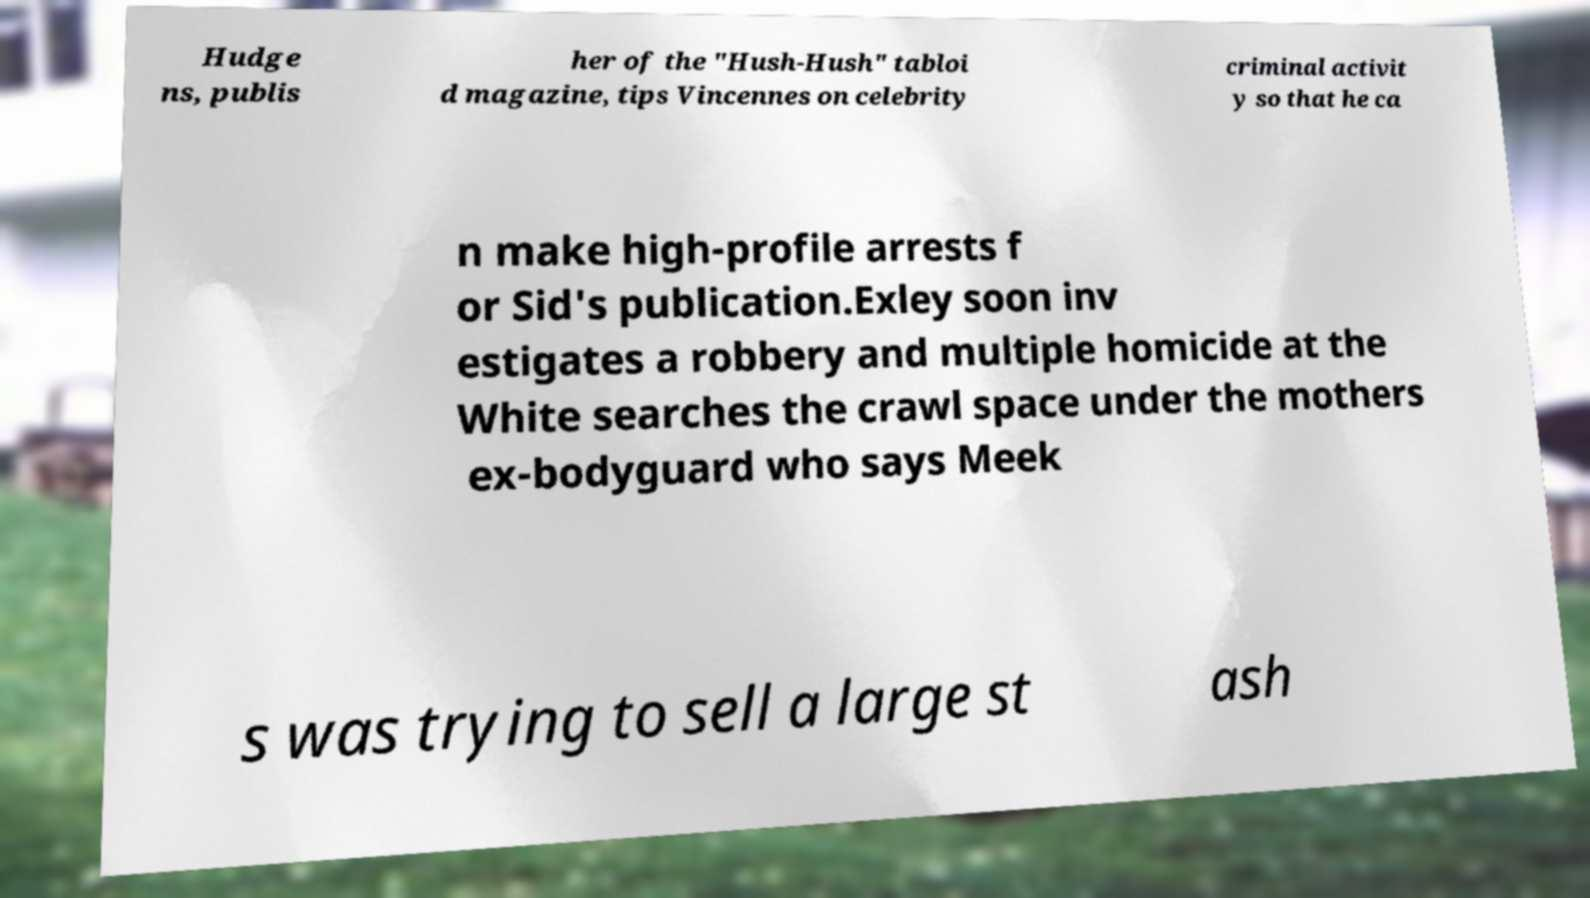I need the written content from this picture converted into text. Can you do that? Hudge ns, publis her of the "Hush-Hush" tabloi d magazine, tips Vincennes on celebrity criminal activit y so that he ca n make high-profile arrests f or Sid's publication.Exley soon inv estigates a robbery and multiple homicide at the White searches the crawl space under the mothers ex-bodyguard who says Meek s was trying to sell a large st ash 